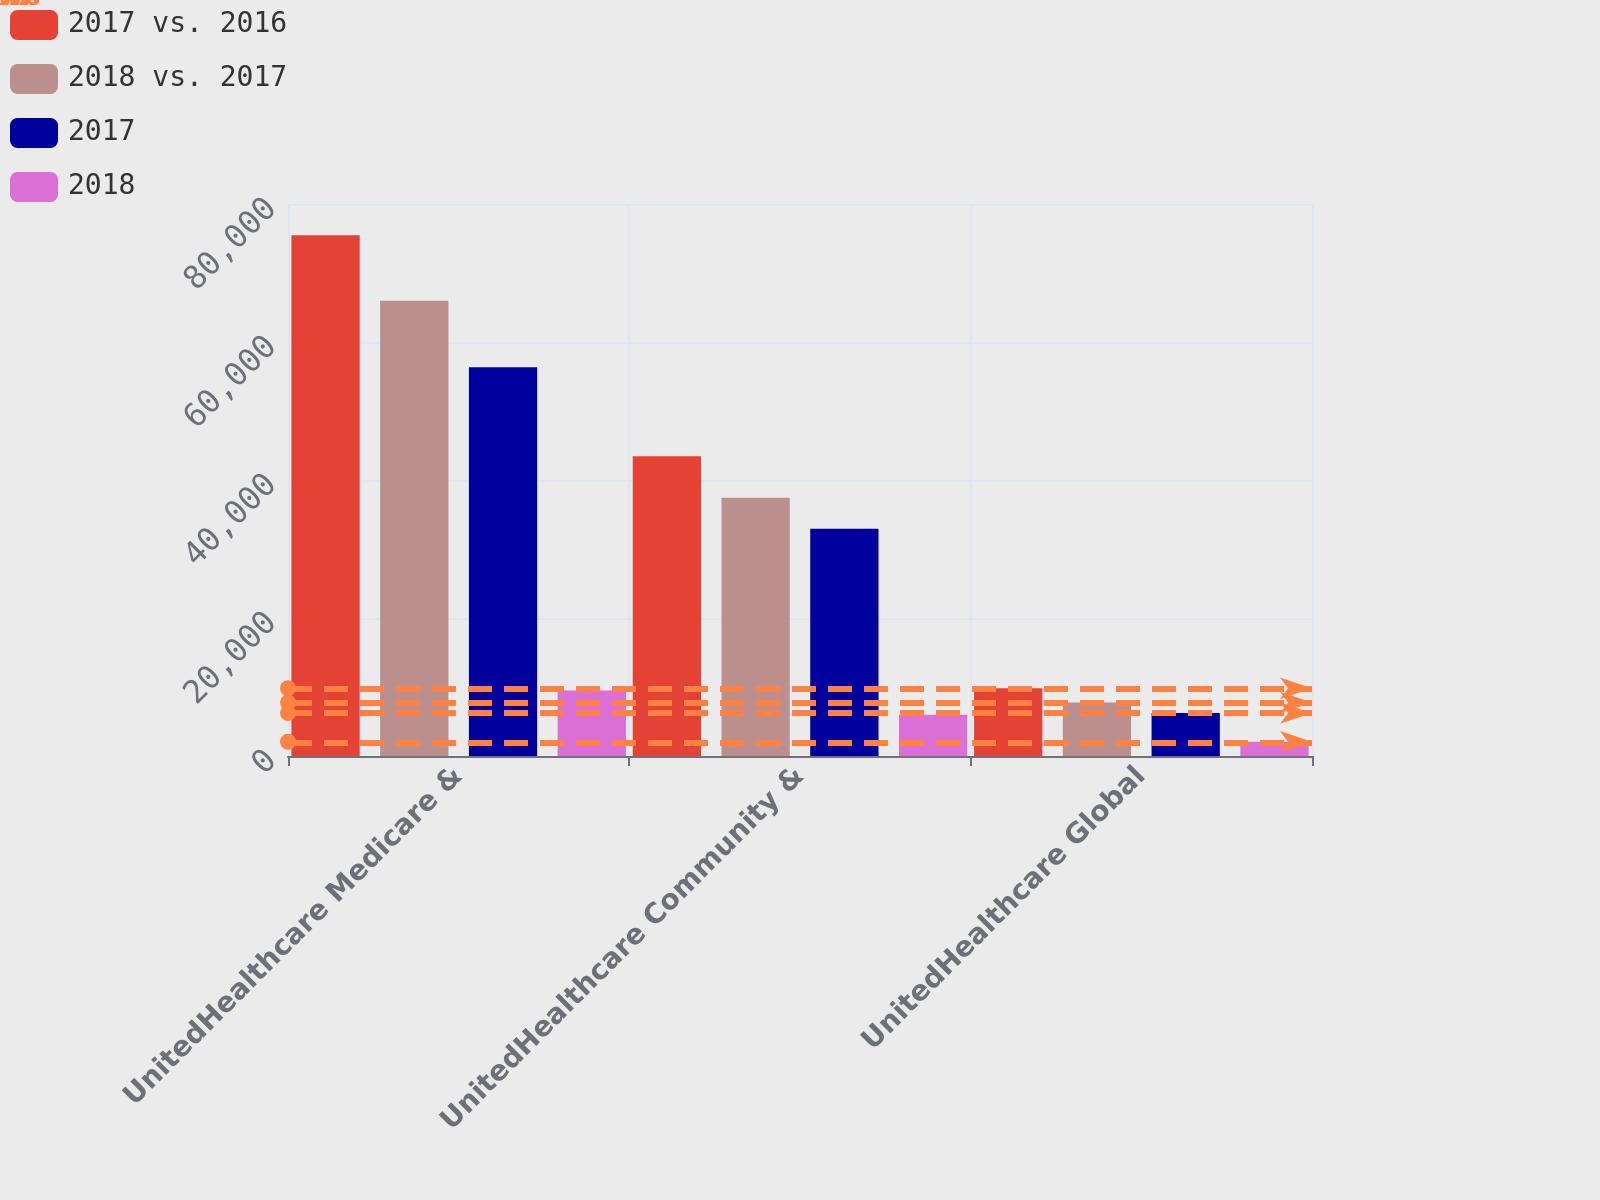Convert chart to OTSL. <chart><loc_0><loc_0><loc_500><loc_500><stacked_bar_chart><ecel><fcel>UnitedHealthcare Medicare &<fcel>UnitedHealthcare Community &<fcel>UnitedHealthcare Global<nl><fcel>2017 vs. 2016<fcel>75473<fcel>43426<fcel>9816<nl><fcel>2018 vs. 2017<fcel>65995<fcel>37443<fcel>7753<nl><fcel>2017<fcel>56329<fcel>32945<fcel>6223<nl><fcel>2018<fcel>9478<fcel>5983<fcel>2063<nl></chart> 